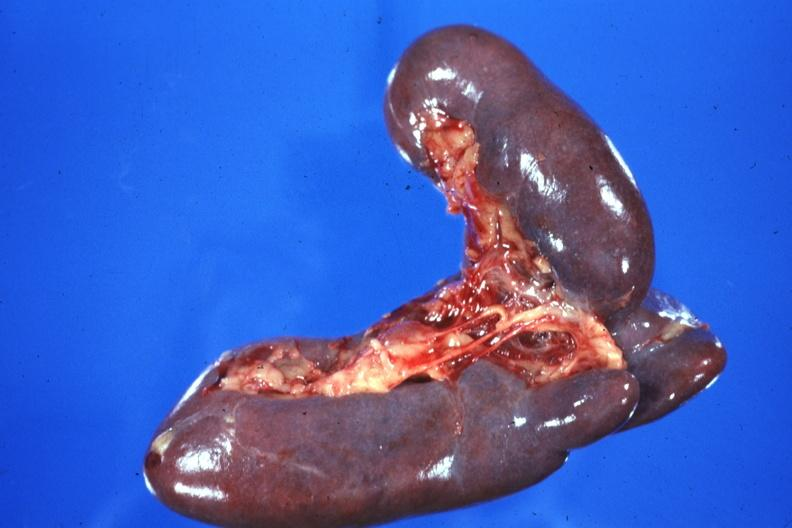does fallopian tube show external view case of situs ambiguous partial left isomerism?
Answer the question using a single word or phrase. No 